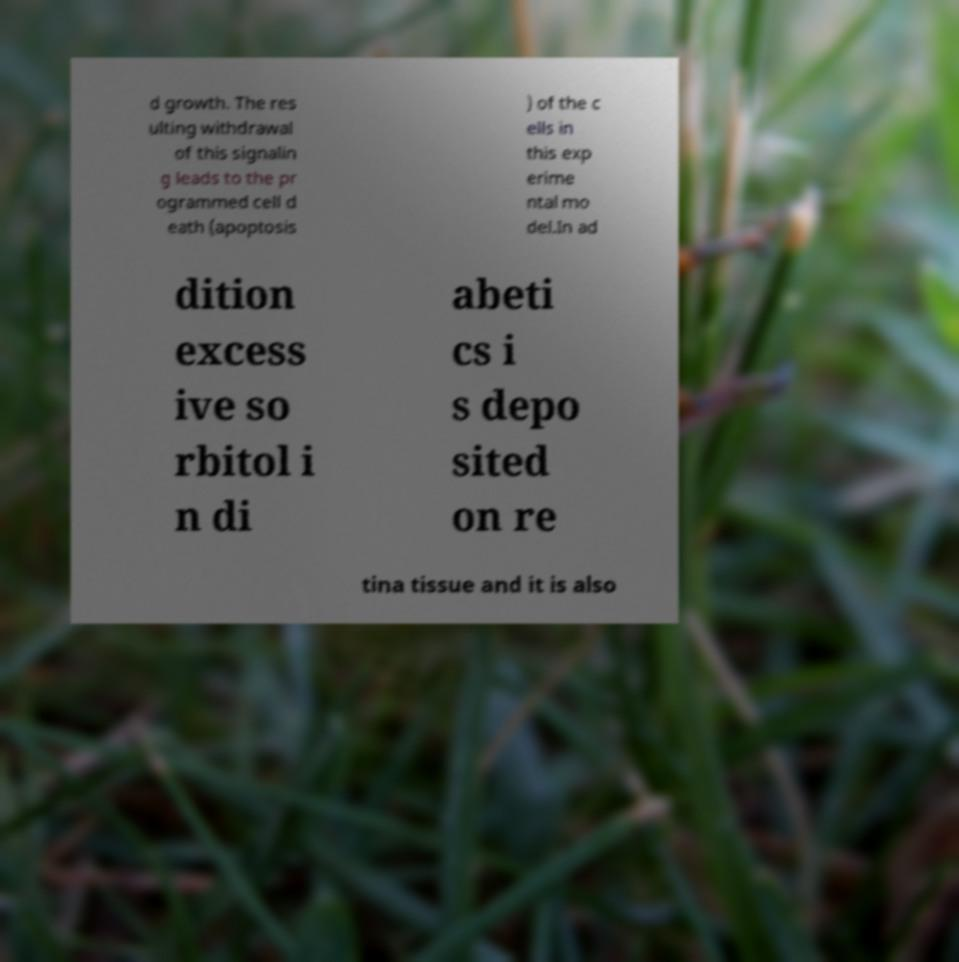What messages or text are displayed in this image? I need them in a readable, typed format. d growth. The res ulting withdrawal of this signalin g leads to the pr ogrammed cell d eath (apoptosis ) of the c ells in this exp erime ntal mo del.In ad dition excess ive so rbitol i n di abeti cs i s depo sited on re tina tissue and it is also 